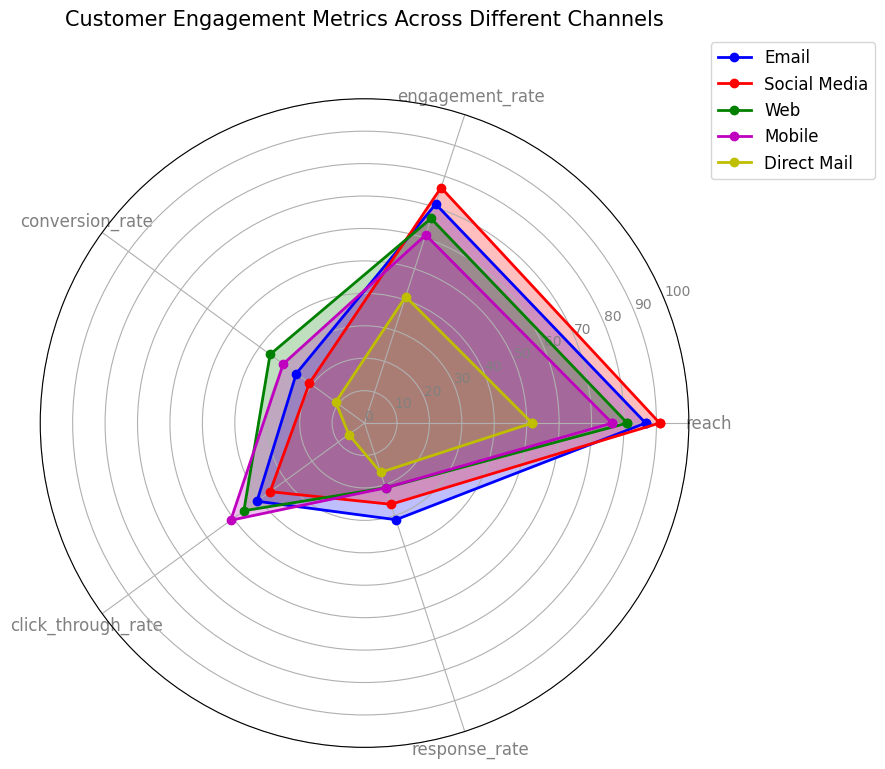Which channel has the highest reach? By examining the values on the chart, Social Media has the highest point on the reach axis.
Answer: Social Media Which channel has the lowest conversion rate? By looking at the points closest to the center on the conversion rate axis, Direct Mail has the lowest conversion rate.
Answer: Direct Mail Which channel shows the most balanced performance across all metrics? Observing the shapes plotted, Email and Social Media both appear more balanced with consistently high values across the axes.
Answer: Email, Social Media Compare the engagement rate of Social Media and Web. Which is higher? The engagement rate point for Social Media is higher on the engagement rate axis compared to Web.
Answer: Social Media Which metrics have the smallest difference between Email and Mobile? Both obtaining similar values for click-through rate and response rate when checking their respective points along these axes.
Answer: Click-through rate, Response rate What is the average engagement rate across all channels? Adding the engagement rates of all channels (70 + 75 + 65 + 60 + 40 = 310) and dividing by the number of channels (5) gives 62.
Answer: 62 Which channel has the highest click-through rate? By observing the outermost point on the click-through rate axis, Mobile has the highest click-through rate.
Answer: Mobile How does Direct Mail compare to other channels in terms of response rate? Direct Mail has one of the lower response rates, as its point on the response rate axis is near the center compared to the other channels.
Answer: Lower than others What is the combined reach of Email and Web? Summing the values for reach for Email (85) and Web (80) results in a total reach of 165.
Answer: 165 Which metric shows the most variation among the channels? Visually, the click-through rate axis has widely dispersed points, indicating the most variation among the channels.
Answer: Click-through rate 